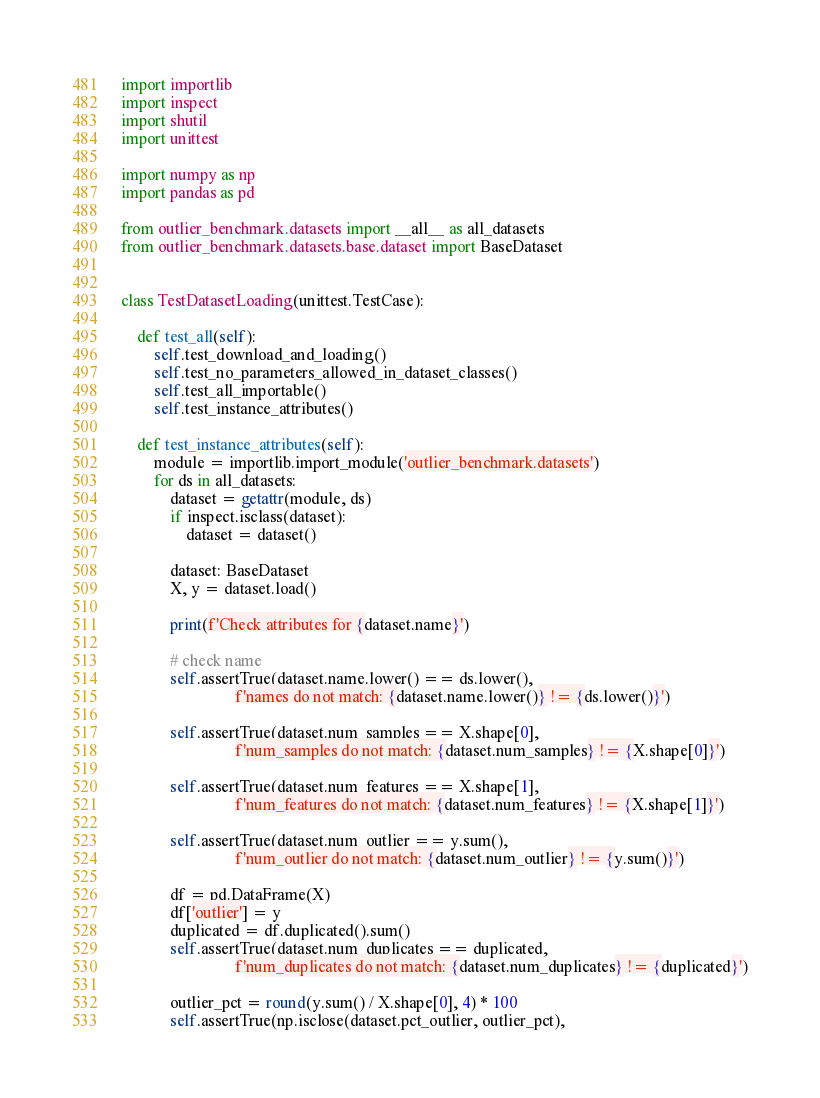<code> <loc_0><loc_0><loc_500><loc_500><_Python_>import importlib
import inspect
import shutil
import unittest

import numpy as np
import pandas as pd

from outlier_benchmark.datasets import __all__ as all_datasets
from outlier_benchmark.datasets.base.dataset import BaseDataset


class TestDatasetLoading(unittest.TestCase):

    def test_all(self):
        self.test_download_and_loading()
        self.test_no_parameters_allowed_in_dataset_classes()
        self.test_all_importable()
        self.test_instance_attributes()

    def test_instance_attributes(self):
        module = importlib.import_module('outlier_benchmark.datasets')
        for ds in all_datasets:
            dataset = getattr(module, ds)
            if inspect.isclass(dataset):
                dataset = dataset()

            dataset: BaseDataset
            X, y = dataset.load()

            print(f'Check attributes for {dataset.name}')

            # check name
            self.assertTrue(dataset.name.lower() == ds.lower(),
                            f'names do not match: {dataset.name.lower()} != {ds.lower()}')

            self.assertTrue(dataset.num_samples == X.shape[0],
                            f'num_samples do not match: {dataset.num_samples} != {X.shape[0]}')

            self.assertTrue(dataset.num_features == X.shape[1],
                            f'num_features do not match: {dataset.num_features} != {X.shape[1]}')

            self.assertTrue(dataset.num_outlier == y.sum(),
                            f'num_outlier do not match: {dataset.num_outlier} != {y.sum()}')

            df = pd.DataFrame(X)
            df['outlier'] = y
            duplicated = df.duplicated().sum()
            self.assertTrue(dataset.num_duplicates == duplicated,
                            f'num_duplicates do not match: {dataset.num_duplicates} != {duplicated}')

            outlier_pct = round(y.sum() / X.shape[0], 4) * 100
            self.assertTrue(np.isclose(dataset.pct_outlier, outlier_pct),</code> 